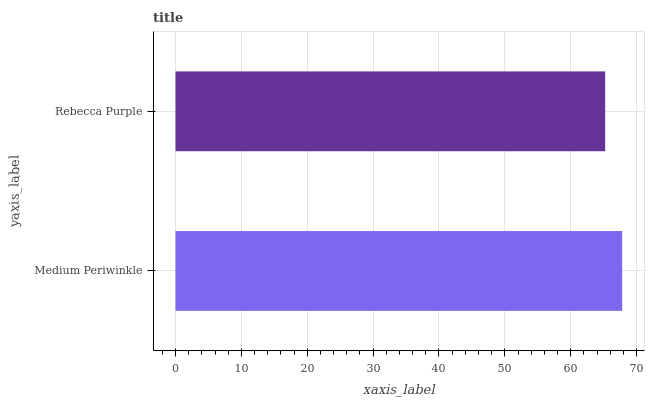Is Rebecca Purple the minimum?
Answer yes or no. Yes. Is Medium Periwinkle the maximum?
Answer yes or no. Yes. Is Rebecca Purple the maximum?
Answer yes or no. No. Is Medium Periwinkle greater than Rebecca Purple?
Answer yes or no. Yes. Is Rebecca Purple less than Medium Periwinkle?
Answer yes or no. Yes. Is Rebecca Purple greater than Medium Periwinkle?
Answer yes or no. No. Is Medium Periwinkle less than Rebecca Purple?
Answer yes or no. No. Is Medium Periwinkle the high median?
Answer yes or no. Yes. Is Rebecca Purple the low median?
Answer yes or no. Yes. Is Rebecca Purple the high median?
Answer yes or no. No. Is Medium Periwinkle the low median?
Answer yes or no. No. 